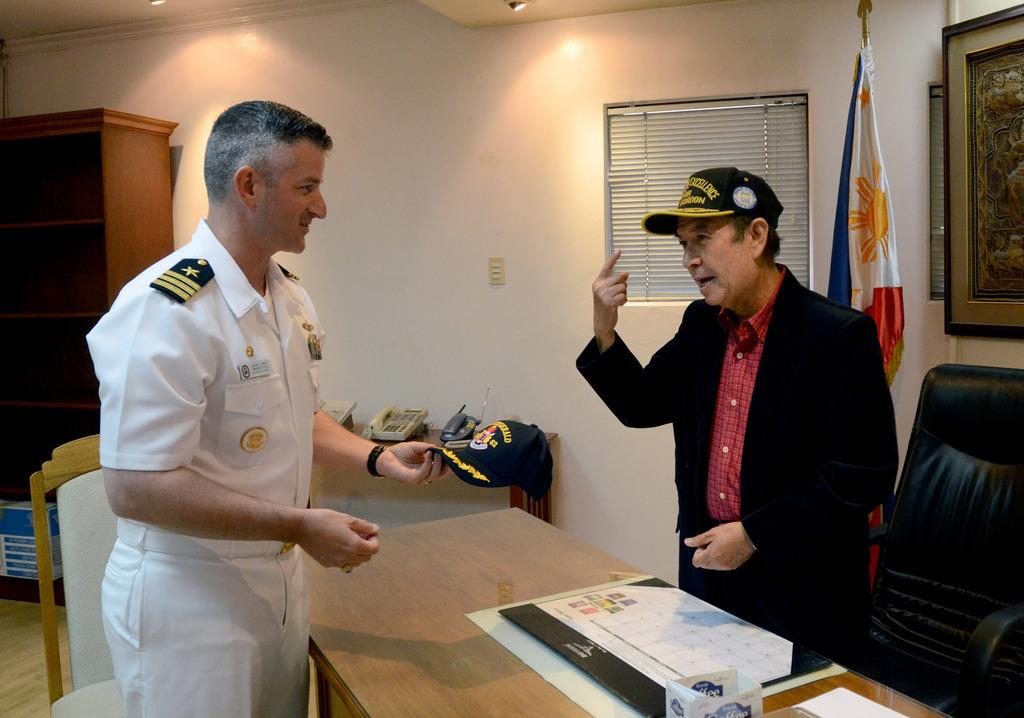How many people are present in the image? There are two persons standing in the image. What can be seen in the background of the image? There is a wall in the image. Are there any objects on the wall? Yes, there are photo frames on the wall. What is located in the middle of the image? There is a table in the image. What is on the table? There are objects on the table. Can you describe the flag in the image? Yes, there is a flag in the image. What type of skirt is the flag made of in the image? The flag in the image is not made of a skirt; it is made of fabric. Is there a veil covering the photo frames on the wall? There is no veil present in the image; the photo frames are visible. 